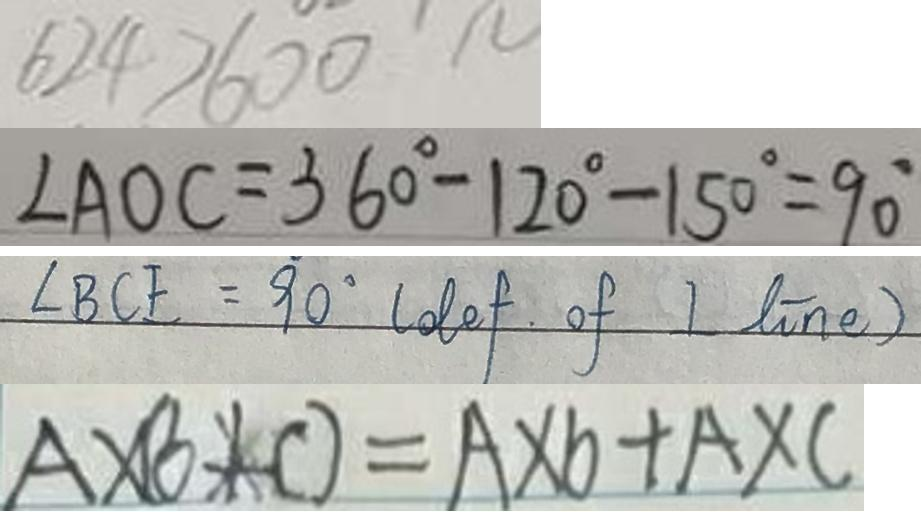<formula> <loc_0><loc_0><loc_500><loc_500>6 2 4 > 6 0 0 
 \angle A O C = 3 6 0 ^ { \circ } - 1 2 0 ^ { \circ } - 1 5 0 ^ { \circ } = 9 0 ^ { \circ } 
 \angle B C E = 9 0 ^ { \circ } ( o t e f \cdot o f I t i n e ) 
 A \times ( b + c ) = A \times b + A \times c</formula> 